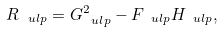<formula> <loc_0><loc_0><loc_500><loc_500>R _ { \ u l p } = G _ { \ u l p } ^ { 2 } - F _ { \ u l p } H _ { \ u l p } ,</formula> 